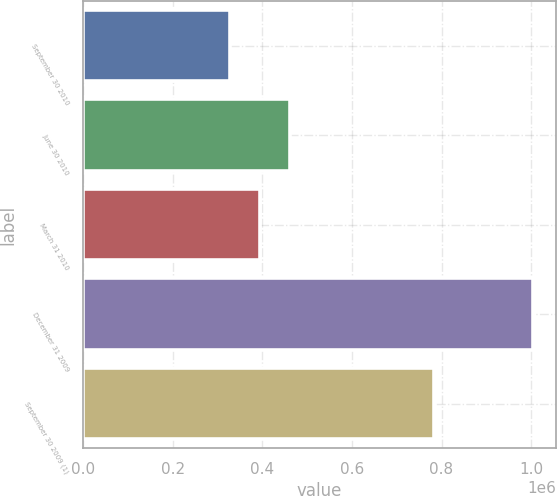<chart> <loc_0><loc_0><loc_500><loc_500><bar_chart><fcel>September 30 2010<fcel>June 30 2010<fcel>March 31 2010<fcel>December 31 2009<fcel>September 30 2009 (1)<nl><fcel>326927<fcel>462452<fcel>394690<fcel>1.00455e+06<fcel>783416<nl></chart> 